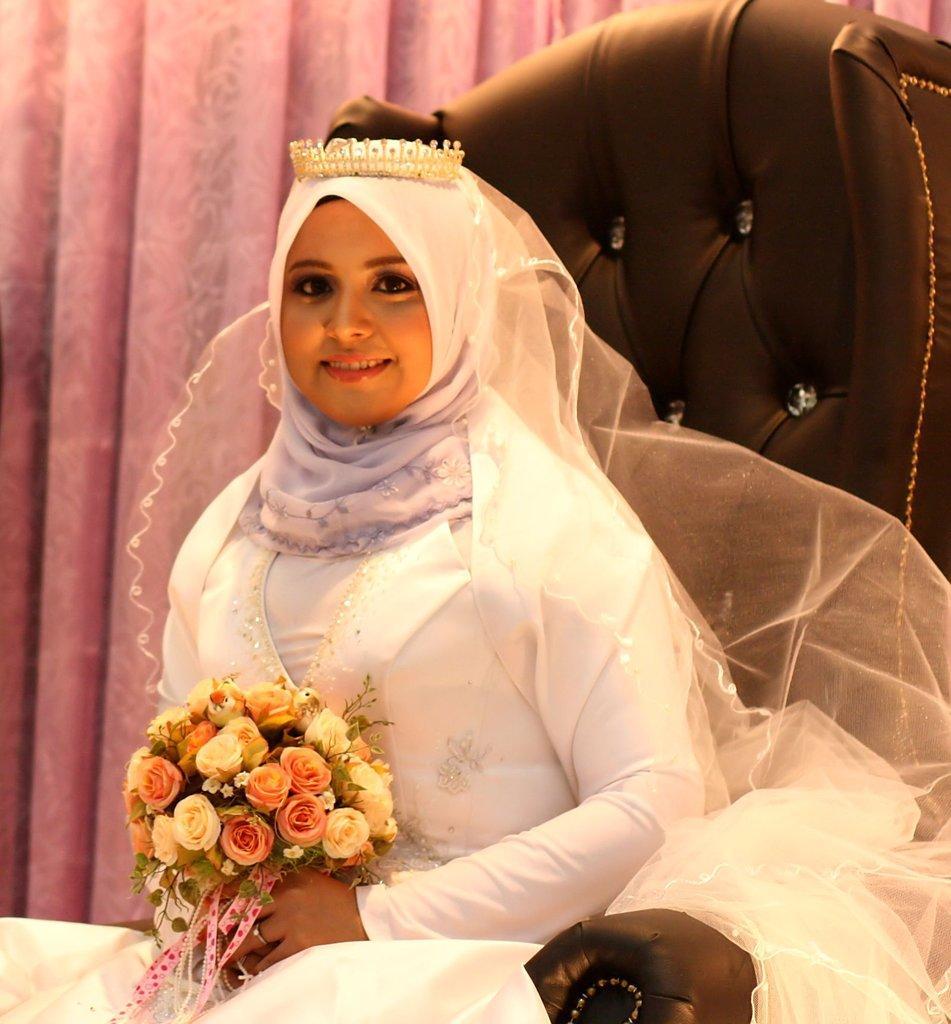In one or two sentences, can you explain what this image depicts? In the center of the image there is a woman sitting on the chair holding a bouquet. In the background there is a curtain. 